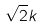Convert formula to latex. <formula><loc_0><loc_0><loc_500><loc_500>\sqrt { 2 } k</formula> 